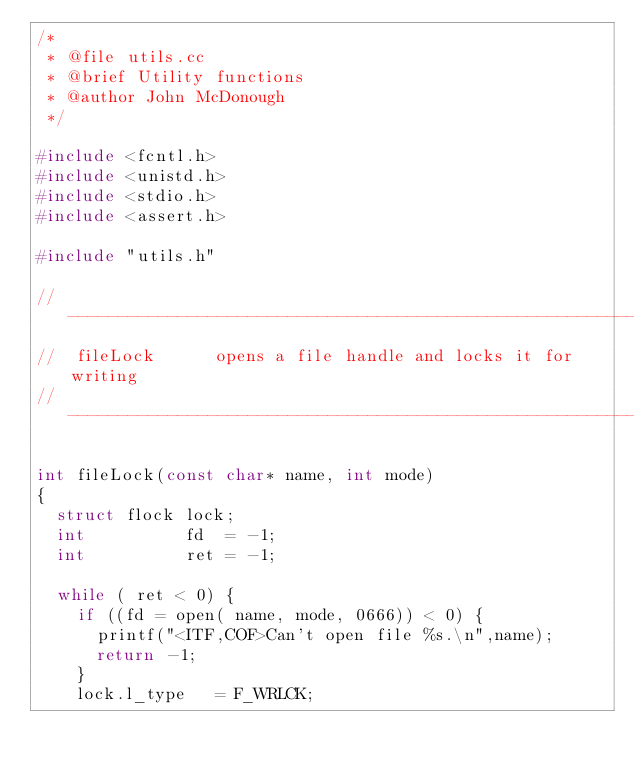<code> <loc_0><loc_0><loc_500><loc_500><_C++_>/*
 * @file utils.cc
 * @brief Utility functions
 * @author John McDonough
 */

#include <fcntl.h>
#include <unistd.h>
#include <stdio.h>
#include <assert.h>

#include "utils.h"

// ------------------------------------------------------------------------
//  fileLock      opens a file handle and locks it for writing
// ------------------------------------------------------------------------

int fileLock(const char* name, int mode)
{
  struct flock lock;
  int          fd  = -1;
  int          ret = -1;

  while ( ret < 0) {
    if ((fd = open( name, mode, 0666)) < 0) {
      printf("<ITF,COF>Can't open file %s.\n",name);
      return -1;
    }
    lock.l_type   = F_WRLCK;</code> 